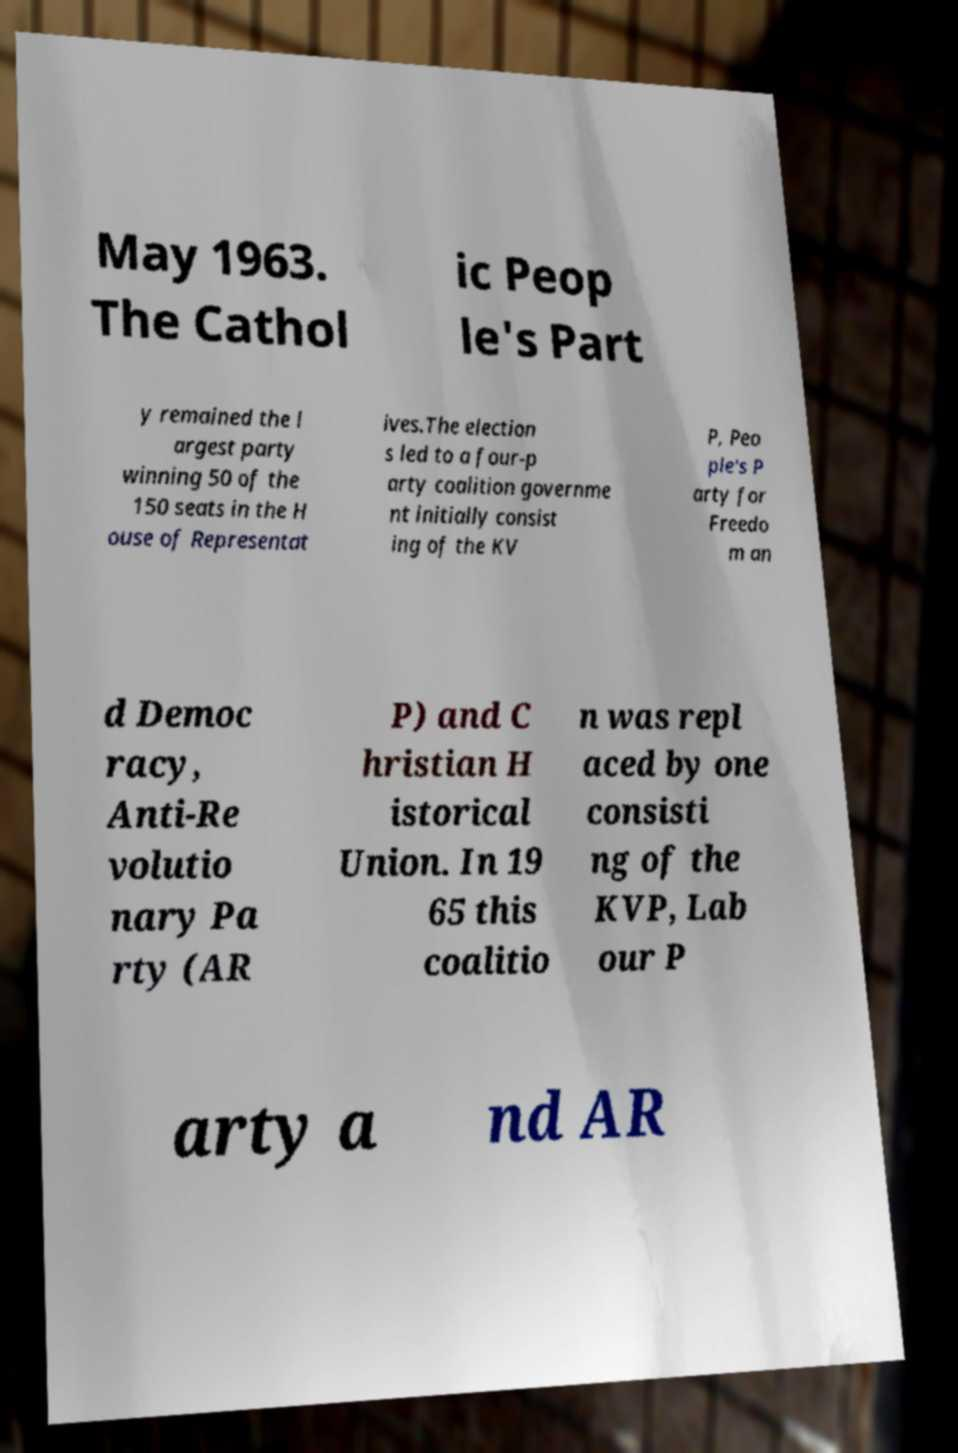Can you accurately transcribe the text from the provided image for me? May 1963. The Cathol ic Peop le's Part y remained the l argest party winning 50 of the 150 seats in the H ouse of Representat ives.The election s led to a four-p arty coalition governme nt initially consist ing of the KV P, Peo ple's P arty for Freedo m an d Democ racy, Anti-Re volutio nary Pa rty (AR P) and C hristian H istorical Union. In 19 65 this coalitio n was repl aced by one consisti ng of the KVP, Lab our P arty a nd AR 